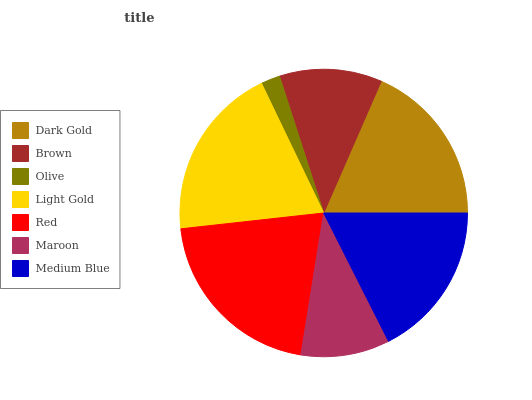Is Olive the minimum?
Answer yes or no. Yes. Is Red the maximum?
Answer yes or no. Yes. Is Brown the minimum?
Answer yes or no. No. Is Brown the maximum?
Answer yes or no. No. Is Dark Gold greater than Brown?
Answer yes or no. Yes. Is Brown less than Dark Gold?
Answer yes or no. Yes. Is Brown greater than Dark Gold?
Answer yes or no. No. Is Dark Gold less than Brown?
Answer yes or no. No. Is Medium Blue the high median?
Answer yes or no. Yes. Is Medium Blue the low median?
Answer yes or no. Yes. Is Olive the high median?
Answer yes or no. No. Is Light Gold the low median?
Answer yes or no. No. 